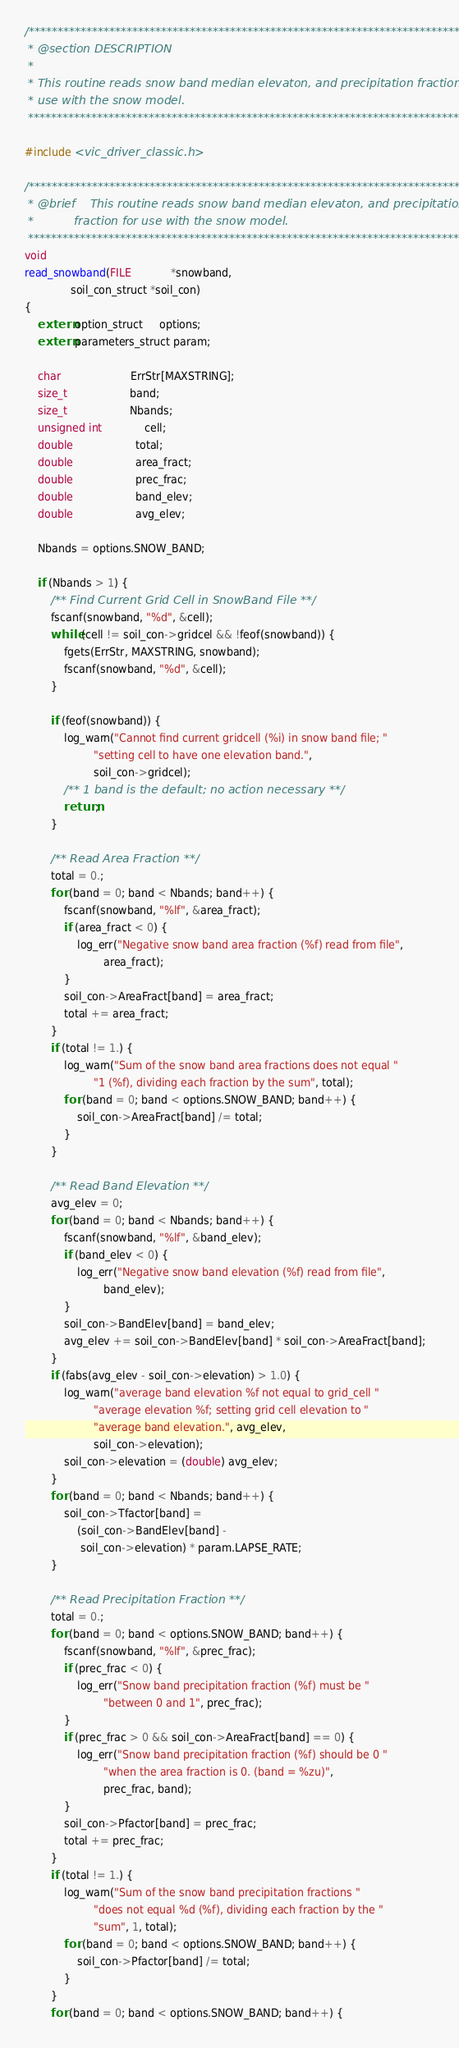<code> <loc_0><loc_0><loc_500><loc_500><_C_>/******************************************************************************
 * @section DESCRIPTION
 *
 * This routine reads snow band median elevaton, and precipitation fraction for
 * use with the snow model.
 *****************************************************************************/

#include <vic_driver_classic.h>

/******************************************************************************
 * @brief    This routine reads snow band median elevaton, and precipitation
 *           fraction for use with the snow model.
 *****************************************************************************/
void
read_snowband(FILE            *snowband,
              soil_con_struct *soil_con)
{
    extern option_struct     options;
    extern parameters_struct param;

    char                     ErrStr[MAXSTRING];
    size_t                   band;
    size_t                   Nbands;
    unsigned int             cell;
    double                   total;
    double                   area_fract;
    double                   prec_frac;
    double                   band_elev;
    double                   avg_elev;

    Nbands = options.SNOW_BAND;

    if (Nbands > 1) {
        /** Find Current Grid Cell in SnowBand File **/
        fscanf(snowband, "%d", &cell);
        while (cell != soil_con->gridcel && !feof(snowband)) {
            fgets(ErrStr, MAXSTRING, snowband);
            fscanf(snowband, "%d", &cell);
        }

        if (feof(snowband)) {
            log_warn("Cannot find current gridcell (%i) in snow band file; "
                     "setting cell to have one elevation band.",
                     soil_con->gridcel);
            /** 1 band is the default; no action necessary **/
            return;
        }

        /** Read Area Fraction **/
        total = 0.;
        for (band = 0; band < Nbands; band++) {
            fscanf(snowband, "%lf", &area_fract);
            if (area_fract < 0) {
                log_err("Negative snow band area fraction (%f) read from file",
                        area_fract);
            }
            soil_con->AreaFract[band] = area_fract;
            total += area_fract;
        }
        if (total != 1.) {
            log_warn("Sum of the snow band area fractions does not equal "
                     "1 (%f), dividing each fraction by the sum", total);
            for (band = 0; band < options.SNOW_BAND; band++) {
                soil_con->AreaFract[band] /= total;
            }
        }

        /** Read Band Elevation **/
        avg_elev = 0;
        for (band = 0; band < Nbands; band++) {
            fscanf(snowband, "%lf", &band_elev);
            if (band_elev < 0) {
                log_err("Negative snow band elevation (%f) read from file",
                        band_elev);
            }
            soil_con->BandElev[band] = band_elev;
            avg_elev += soil_con->BandElev[band] * soil_con->AreaFract[band];
        }
        if (fabs(avg_elev - soil_con->elevation) > 1.0) {
            log_warn("average band elevation %f not equal to grid_cell "
                     "average elevation %f; setting grid cell elevation to "
                     "average band elevation.", avg_elev,
                     soil_con->elevation);
            soil_con->elevation = (double) avg_elev;
        }
        for (band = 0; band < Nbands; band++) {
            soil_con->Tfactor[band] =
                (soil_con->BandElev[band] -
                 soil_con->elevation) * param.LAPSE_RATE;
        }

        /** Read Precipitation Fraction **/
        total = 0.;
        for (band = 0; band < options.SNOW_BAND; band++) {
            fscanf(snowband, "%lf", &prec_frac);
            if (prec_frac < 0) {
                log_err("Snow band precipitation fraction (%f) must be "
                        "between 0 and 1", prec_frac);
            }
            if (prec_frac > 0 && soil_con->AreaFract[band] == 0) {
                log_err("Snow band precipitation fraction (%f) should be 0 "
                        "when the area fraction is 0. (band = %zu)",
                        prec_frac, band);
            }
            soil_con->Pfactor[band] = prec_frac;
            total += prec_frac;
        }
        if (total != 1.) {
            log_warn("Sum of the snow band precipitation fractions "
                     "does not equal %d (%f), dividing each fraction by the "
                     "sum", 1, total);
            for (band = 0; band < options.SNOW_BAND; band++) {
                soil_con->Pfactor[band] /= total;
            }
        }
        for (band = 0; band < options.SNOW_BAND; band++) {</code> 